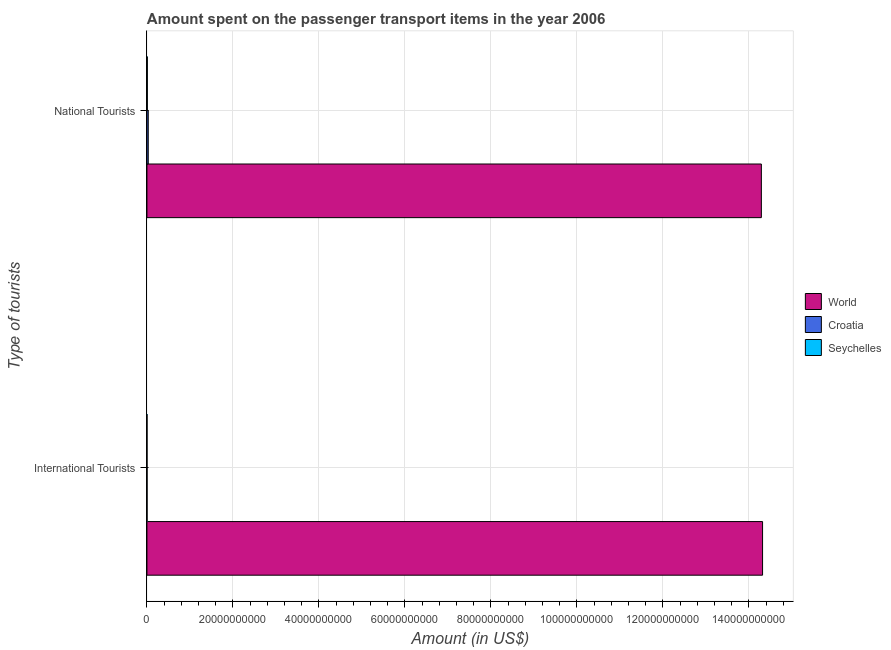How many groups of bars are there?
Your response must be concise. 2. Are the number of bars per tick equal to the number of legend labels?
Your response must be concise. Yes. Are the number of bars on each tick of the Y-axis equal?
Offer a very short reply. Yes. How many bars are there on the 1st tick from the top?
Offer a very short reply. 3. What is the label of the 1st group of bars from the top?
Provide a succinct answer. National Tourists. What is the amount spent on transport items of national tourists in Seychelles?
Make the answer very short. 9.50e+07. Across all countries, what is the maximum amount spent on transport items of international tourists?
Make the answer very short. 1.43e+11. In which country was the amount spent on transport items of national tourists maximum?
Provide a succinct answer. World. In which country was the amount spent on transport items of international tourists minimum?
Ensure brevity in your answer.  Seychelles. What is the total amount spent on transport items of international tourists in the graph?
Provide a succinct answer. 1.43e+11. What is the difference between the amount spent on transport items of national tourists in Seychelles and that in World?
Give a very brief answer. -1.43e+11. What is the difference between the amount spent on transport items of international tourists in Croatia and the amount spent on transport items of national tourists in World?
Offer a very short reply. -1.43e+11. What is the average amount spent on transport items of international tourists per country?
Keep it short and to the point. 4.77e+1. What is the difference between the amount spent on transport items of international tourists and amount spent on transport items of national tourists in Croatia?
Give a very brief answer. -2.73e+08. In how many countries, is the amount spent on transport items of national tourists greater than 60000000000 US$?
Give a very brief answer. 1. What is the ratio of the amount spent on transport items of national tourists in Croatia to that in Seychelles?
Provide a short and direct response. 3.22. In how many countries, is the amount spent on transport items of national tourists greater than the average amount spent on transport items of national tourists taken over all countries?
Keep it short and to the point. 1. What does the 3rd bar from the top in National Tourists represents?
Offer a terse response. World. What does the 2nd bar from the bottom in International Tourists represents?
Offer a terse response. Croatia. How many bars are there?
Keep it short and to the point. 6. Are all the bars in the graph horizontal?
Your response must be concise. Yes. How many countries are there in the graph?
Ensure brevity in your answer.  3. Does the graph contain grids?
Provide a short and direct response. Yes. Where does the legend appear in the graph?
Make the answer very short. Center right. How are the legend labels stacked?
Provide a short and direct response. Vertical. What is the title of the graph?
Ensure brevity in your answer.  Amount spent on the passenger transport items in the year 2006. Does "Tunisia" appear as one of the legend labels in the graph?
Ensure brevity in your answer.  No. What is the label or title of the Y-axis?
Keep it short and to the point. Type of tourists. What is the Amount (in US$) of World in International Tourists?
Your response must be concise. 1.43e+11. What is the Amount (in US$) of Croatia in International Tourists?
Provide a short and direct response. 3.30e+07. What is the Amount (in US$) of World in National Tourists?
Ensure brevity in your answer.  1.43e+11. What is the Amount (in US$) of Croatia in National Tourists?
Give a very brief answer. 3.06e+08. What is the Amount (in US$) in Seychelles in National Tourists?
Provide a succinct answer. 9.50e+07. Across all Type of tourists, what is the maximum Amount (in US$) of World?
Your response must be concise. 1.43e+11. Across all Type of tourists, what is the maximum Amount (in US$) of Croatia?
Provide a succinct answer. 3.06e+08. Across all Type of tourists, what is the maximum Amount (in US$) in Seychelles?
Your response must be concise. 9.50e+07. Across all Type of tourists, what is the minimum Amount (in US$) of World?
Your response must be concise. 1.43e+11. Across all Type of tourists, what is the minimum Amount (in US$) of Croatia?
Offer a very short reply. 3.30e+07. What is the total Amount (in US$) of World in the graph?
Provide a succinct answer. 2.86e+11. What is the total Amount (in US$) of Croatia in the graph?
Your answer should be compact. 3.39e+08. What is the total Amount (in US$) of Seychelles in the graph?
Provide a succinct answer. 1.15e+08. What is the difference between the Amount (in US$) in World in International Tourists and that in National Tourists?
Make the answer very short. 2.82e+08. What is the difference between the Amount (in US$) of Croatia in International Tourists and that in National Tourists?
Your answer should be very brief. -2.73e+08. What is the difference between the Amount (in US$) of Seychelles in International Tourists and that in National Tourists?
Provide a short and direct response. -7.50e+07. What is the difference between the Amount (in US$) of World in International Tourists and the Amount (in US$) of Croatia in National Tourists?
Your response must be concise. 1.43e+11. What is the difference between the Amount (in US$) of World in International Tourists and the Amount (in US$) of Seychelles in National Tourists?
Keep it short and to the point. 1.43e+11. What is the difference between the Amount (in US$) in Croatia in International Tourists and the Amount (in US$) in Seychelles in National Tourists?
Your response must be concise. -6.20e+07. What is the average Amount (in US$) of World per Type of tourists?
Offer a terse response. 1.43e+11. What is the average Amount (in US$) of Croatia per Type of tourists?
Offer a terse response. 1.70e+08. What is the average Amount (in US$) of Seychelles per Type of tourists?
Ensure brevity in your answer.  5.75e+07. What is the difference between the Amount (in US$) of World and Amount (in US$) of Croatia in International Tourists?
Your response must be concise. 1.43e+11. What is the difference between the Amount (in US$) of World and Amount (in US$) of Seychelles in International Tourists?
Provide a short and direct response. 1.43e+11. What is the difference between the Amount (in US$) of Croatia and Amount (in US$) of Seychelles in International Tourists?
Provide a short and direct response. 1.30e+07. What is the difference between the Amount (in US$) in World and Amount (in US$) in Croatia in National Tourists?
Your answer should be very brief. 1.43e+11. What is the difference between the Amount (in US$) of World and Amount (in US$) of Seychelles in National Tourists?
Your answer should be very brief. 1.43e+11. What is the difference between the Amount (in US$) in Croatia and Amount (in US$) in Seychelles in National Tourists?
Offer a very short reply. 2.11e+08. What is the ratio of the Amount (in US$) in Croatia in International Tourists to that in National Tourists?
Make the answer very short. 0.11. What is the ratio of the Amount (in US$) of Seychelles in International Tourists to that in National Tourists?
Your answer should be compact. 0.21. What is the difference between the highest and the second highest Amount (in US$) in World?
Keep it short and to the point. 2.82e+08. What is the difference between the highest and the second highest Amount (in US$) in Croatia?
Provide a succinct answer. 2.73e+08. What is the difference between the highest and the second highest Amount (in US$) of Seychelles?
Your answer should be compact. 7.50e+07. What is the difference between the highest and the lowest Amount (in US$) of World?
Provide a short and direct response. 2.82e+08. What is the difference between the highest and the lowest Amount (in US$) of Croatia?
Offer a very short reply. 2.73e+08. What is the difference between the highest and the lowest Amount (in US$) of Seychelles?
Your answer should be very brief. 7.50e+07. 